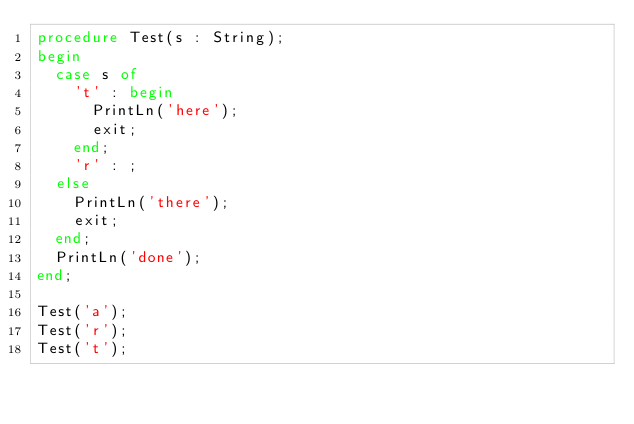Convert code to text. <code><loc_0><loc_0><loc_500><loc_500><_Pascal_>procedure Test(s : String);
begin
	case s of
		't' : begin
			PrintLn('here');
			exit;
		end;
		'r' : ;
	else
		PrintLn('there');
		exit;
	end;
	PrintLn('done');
end;

Test('a');
Test('r');
Test('t');</code> 